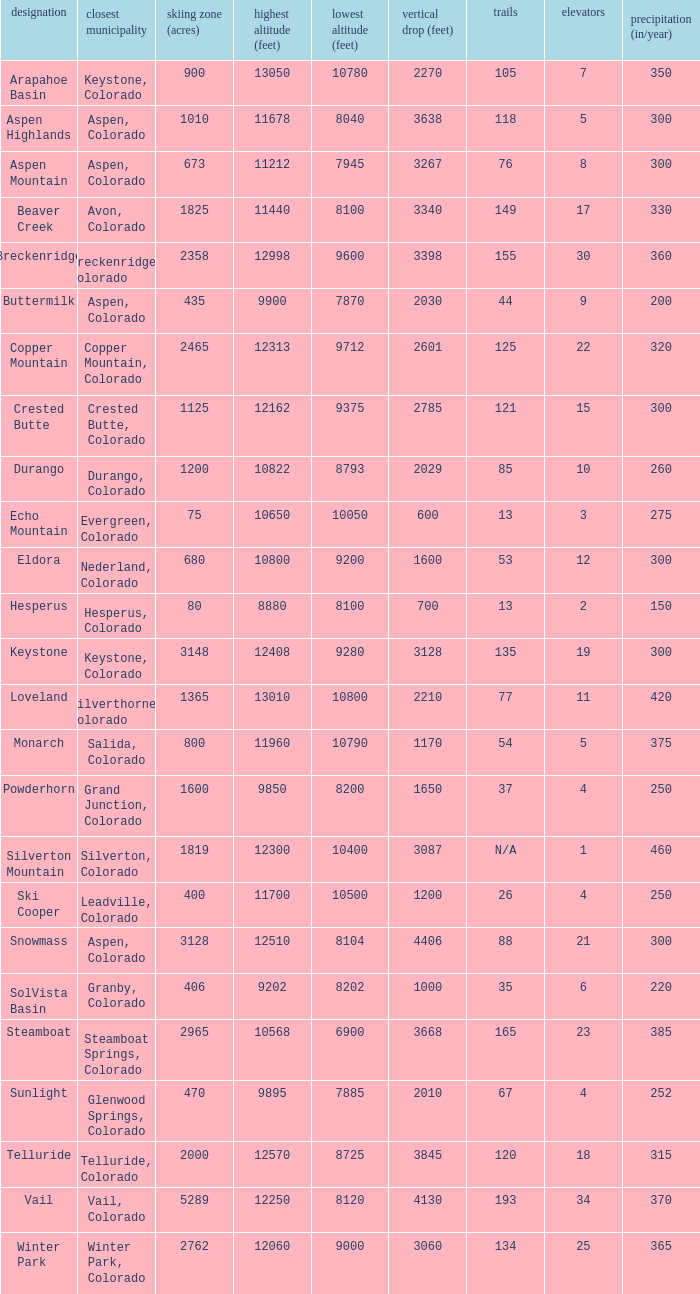If there are 11 lifts, what is the base elevation? 10800.0. 